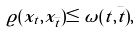Convert formula to latex. <formula><loc_0><loc_0><loc_500><loc_500>\varrho ( x _ { t } , x _ { \bar { t } } ) \leq \omega ( t , \bar { t } ) ,</formula> 